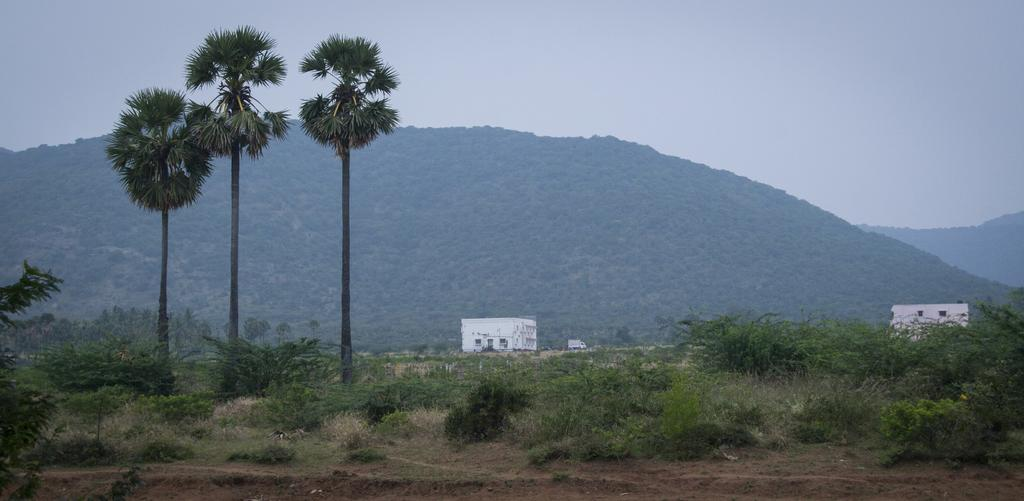What type of vegetation can be seen in the image? There is grass, trees, and plants in the image. What can be seen in the background of the image? There are buildings, a vehicle, hills, and the sky visible in the background of the image. Where is the tub located in the image? There is no tub present in the image. How much dust can be seen on the plants in the image? There is no mention of dust in the image, and the plants appear to be clean. 